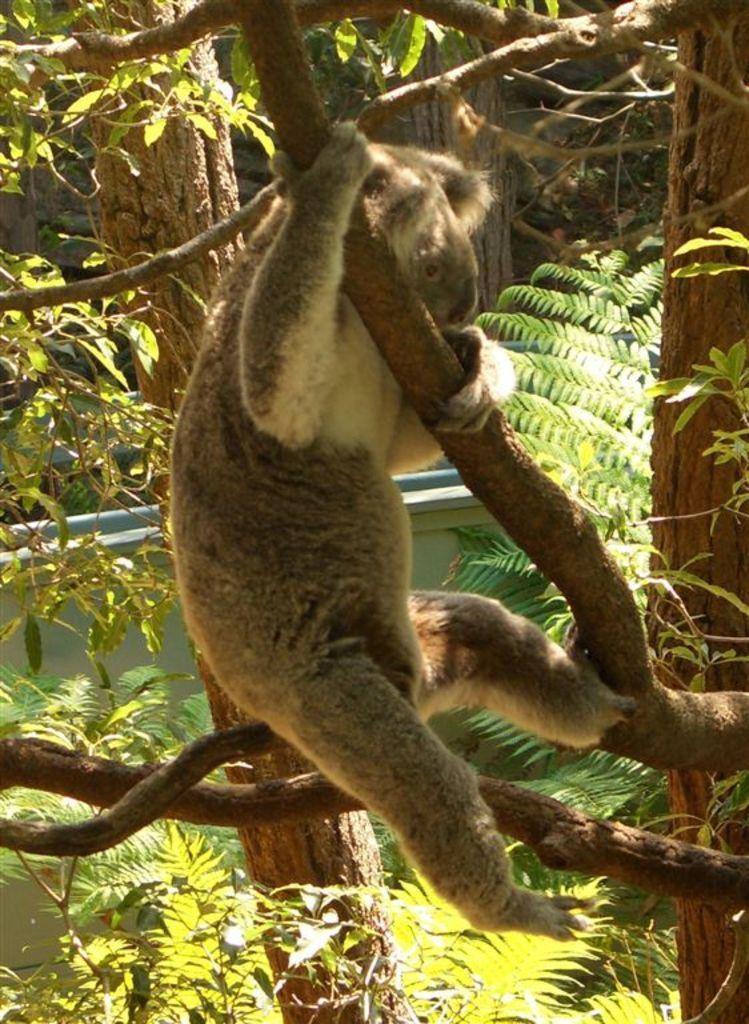Please provide a concise description of this image. In this image I can see an animal which is in brown color and the animal is on the tree. Background I can see water, and trees in green color. 